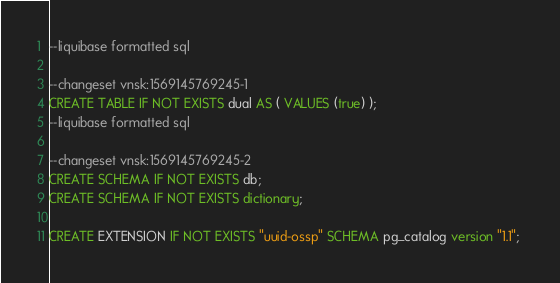<code> <loc_0><loc_0><loc_500><loc_500><_SQL_>--liquibase formatted sql

--changeset vnsk:1569145769245-1
CREATE TABLE IF NOT EXISTS dual AS ( VALUES (true) );
--liquibase formatted sql

--changeset vnsk:1569145769245-2
CREATE SCHEMA IF NOT EXISTS db;
CREATE SCHEMA IF NOT EXISTS dictionary;

CREATE EXTENSION IF NOT EXISTS "uuid-ossp" SCHEMA pg_catalog version "1.1"; 
</code> 